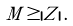<formula> <loc_0><loc_0><loc_500><loc_500>M \geq | Z | \, .</formula> 